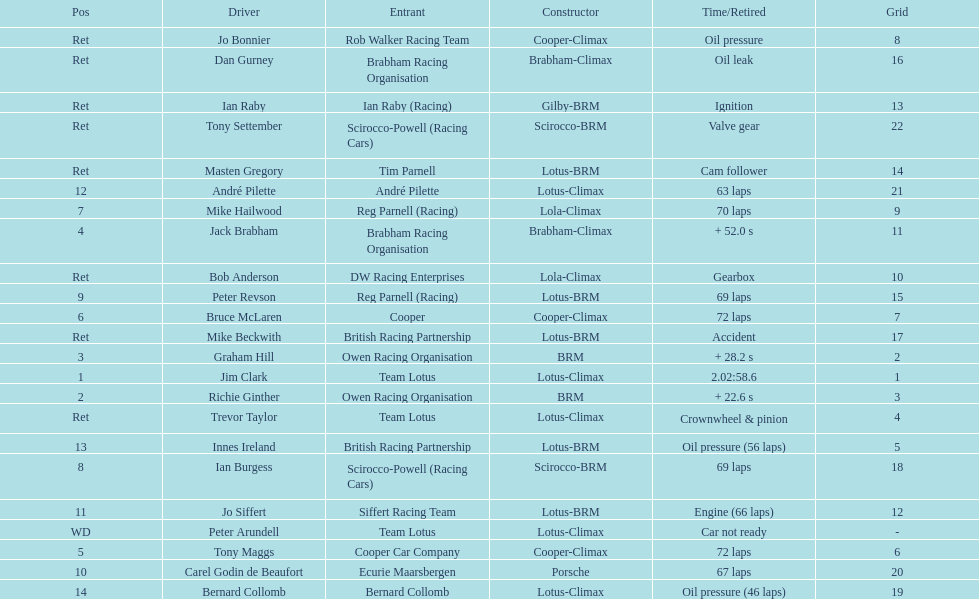How many racers had cooper-climax as their constructor? 3. 